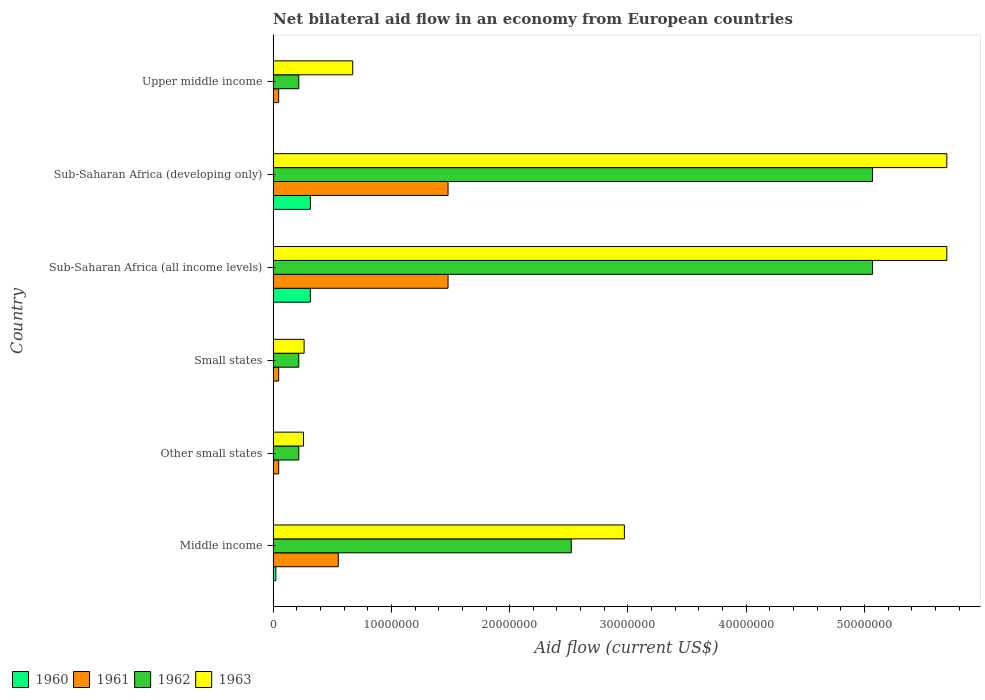How many groups of bars are there?
Your answer should be very brief. 6. How many bars are there on the 4th tick from the top?
Your answer should be compact. 4. What is the label of the 1st group of bars from the top?
Provide a succinct answer. Upper middle income. In how many cases, is the number of bars for a given country not equal to the number of legend labels?
Ensure brevity in your answer.  0. What is the net bilateral aid flow in 1962 in Small states?
Your answer should be compact. 2.17e+06. Across all countries, what is the maximum net bilateral aid flow in 1960?
Your response must be concise. 3.15e+06. Across all countries, what is the minimum net bilateral aid flow in 1962?
Give a very brief answer. 2.17e+06. In which country was the net bilateral aid flow in 1960 maximum?
Provide a short and direct response. Sub-Saharan Africa (all income levels). In which country was the net bilateral aid flow in 1963 minimum?
Keep it short and to the point. Other small states. What is the total net bilateral aid flow in 1963 in the graph?
Your answer should be very brief. 1.56e+08. What is the difference between the net bilateral aid flow in 1960 in Middle income and the net bilateral aid flow in 1962 in Upper middle income?
Your response must be concise. -1.94e+06. What is the average net bilateral aid flow in 1963 per country?
Your answer should be compact. 2.59e+07. What is the difference between the net bilateral aid flow in 1962 and net bilateral aid flow in 1961 in Middle income?
Keep it short and to the point. 1.97e+07. What is the ratio of the net bilateral aid flow in 1962 in Sub-Saharan Africa (developing only) to that in Upper middle income?
Ensure brevity in your answer.  23.35. Is the difference between the net bilateral aid flow in 1962 in Small states and Sub-Saharan Africa (all income levels) greater than the difference between the net bilateral aid flow in 1961 in Small states and Sub-Saharan Africa (all income levels)?
Your answer should be compact. No. What is the difference between the highest and the second highest net bilateral aid flow in 1962?
Your answer should be compact. 0. What is the difference between the highest and the lowest net bilateral aid flow in 1962?
Give a very brief answer. 4.85e+07. Is the sum of the net bilateral aid flow in 1962 in Small states and Sub-Saharan Africa (developing only) greater than the maximum net bilateral aid flow in 1961 across all countries?
Provide a short and direct response. Yes. What does the 4th bar from the top in Middle income represents?
Your answer should be compact. 1960. How many bars are there?
Your answer should be very brief. 24. Does the graph contain grids?
Provide a succinct answer. No. Where does the legend appear in the graph?
Your answer should be very brief. Bottom left. What is the title of the graph?
Offer a terse response. Net bilateral aid flow in an economy from European countries. Does "2005" appear as one of the legend labels in the graph?
Your answer should be compact. No. What is the label or title of the Y-axis?
Make the answer very short. Country. What is the Aid flow (current US$) in 1960 in Middle income?
Keep it short and to the point. 2.30e+05. What is the Aid flow (current US$) of 1961 in Middle income?
Keep it short and to the point. 5.51e+06. What is the Aid flow (current US$) in 1962 in Middle income?
Provide a short and direct response. 2.52e+07. What is the Aid flow (current US$) in 1963 in Middle income?
Your answer should be very brief. 2.97e+07. What is the Aid flow (current US$) in 1960 in Other small states?
Offer a terse response. 10000. What is the Aid flow (current US$) of 1962 in Other small states?
Give a very brief answer. 2.17e+06. What is the Aid flow (current US$) in 1963 in Other small states?
Give a very brief answer. 2.57e+06. What is the Aid flow (current US$) in 1962 in Small states?
Your answer should be very brief. 2.17e+06. What is the Aid flow (current US$) in 1963 in Small states?
Make the answer very short. 2.62e+06. What is the Aid flow (current US$) of 1960 in Sub-Saharan Africa (all income levels)?
Your answer should be compact. 3.15e+06. What is the Aid flow (current US$) of 1961 in Sub-Saharan Africa (all income levels)?
Keep it short and to the point. 1.48e+07. What is the Aid flow (current US$) in 1962 in Sub-Saharan Africa (all income levels)?
Your response must be concise. 5.07e+07. What is the Aid flow (current US$) of 1963 in Sub-Saharan Africa (all income levels)?
Your response must be concise. 5.70e+07. What is the Aid flow (current US$) in 1960 in Sub-Saharan Africa (developing only)?
Give a very brief answer. 3.15e+06. What is the Aid flow (current US$) in 1961 in Sub-Saharan Africa (developing only)?
Your answer should be compact. 1.48e+07. What is the Aid flow (current US$) in 1962 in Sub-Saharan Africa (developing only)?
Your answer should be compact. 5.07e+07. What is the Aid flow (current US$) of 1963 in Sub-Saharan Africa (developing only)?
Your answer should be very brief. 5.70e+07. What is the Aid flow (current US$) of 1961 in Upper middle income?
Your answer should be very brief. 4.70e+05. What is the Aid flow (current US$) of 1962 in Upper middle income?
Your response must be concise. 2.17e+06. What is the Aid flow (current US$) in 1963 in Upper middle income?
Your response must be concise. 6.73e+06. Across all countries, what is the maximum Aid flow (current US$) in 1960?
Offer a very short reply. 3.15e+06. Across all countries, what is the maximum Aid flow (current US$) of 1961?
Make the answer very short. 1.48e+07. Across all countries, what is the maximum Aid flow (current US$) in 1962?
Give a very brief answer. 5.07e+07. Across all countries, what is the maximum Aid flow (current US$) of 1963?
Your response must be concise. 5.70e+07. Across all countries, what is the minimum Aid flow (current US$) of 1960?
Ensure brevity in your answer.  10000. Across all countries, what is the minimum Aid flow (current US$) of 1961?
Make the answer very short. 4.70e+05. Across all countries, what is the minimum Aid flow (current US$) of 1962?
Offer a very short reply. 2.17e+06. Across all countries, what is the minimum Aid flow (current US$) of 1963?
Provide a short and direct response. 2.57e+06. What is the total Aid flow (current US$) in 1960 in the graph?
Your response must be concise. 6.56e+06. What is the total Aid flow (current US$) in 1961 in the graph?
Provide a short and direct response. 3.65e+07. What is the total Aid flow (current US$) of 1962 in the graph?
Provide a short and direct response. 1.33e+08. What is the total Aid flow (current US$) in 1963 in the graph?
Offer a terse response. 1.56e+08. What is the difference between the Aid flow (current US$) of 1960 in Middle income and that in Other small states?
Keep it short and to the point. 2.20e+05. What is the difference between the Aid flow (current US$) of 1961 in Middle income and that in Other small states?
Provide a short and direct response. 5.04e+06. What is the difference between the Aid flow (current US$) of 1962 in Middle income and that in Other small states?
Give a very brief answer. 2.30e+07. What is the difference between the Aid flow (current US$) of 1963 in Middle income and that in Other small states?
Your answer should be very brief. 2.71e+07. What is the difference between the Aid flow (current US$) of 1960 in Middle income and that in Small states?
Your response must be concise. 2.20e+05. What is the difference between the Aid flow (current US$) of 1961 in Middle income and that in Small states?
Your answer should be very brief. 5.04e+06. What is the difference between the Aid flow (current US$) of 1962 in Middle income and that in Small states?
Ensure brevity in your answer.  2.30e+07. What is the difference between the Aid flow (current US$) in 1963 in Middle income and that in Small states?
Ensure brevity in your answer.  2.71e+07. What is the difference between the Aid flow (current US$) of 1960 in Middle income and that in Sub-Saharan Africa (all income levels)?
Your response must be concise. -2.92e+06. What is the difference between the Aid flow (current US$) in 1961 in Middle income and that in Sub-Saharan Africa (all income levels)?
Provide a short and direct response. -9.28e+06. What is the difference between the Aid flow (current US$) in 1962 in Middle income and that in Sub-Saharan Africa (all income levels)?
Your response must be concise. -2.55e+07. What is the difference between the Aid flow (current US$) in 1963 in Middle income and that in Sub-Saharan Africa (all income levels)?
Your answer should be compact. -2.73e+07. What is the difference between the Aid flow (current US$) of 1960 in Middle income and that in Sub-Saharan Africa (developing only)?
Provide a short and direct response. -2.92e+06. What is the difference between the Aid flow (current US$) in 1961 in Middle income and that in Sub-Saharan Africa (developing only)?
Offer a terse response. -9.28e+06. What is the difference between the Aid flow (current US$) of 1962 in Middle income and that in Sub-Saharan Africa (developing only)?
Offer a terse response. -2.55e+07. What is the difference between the Aid flow (current US$) of 1963 in Middle income and that in Sub-Saharan Africa (developing only)?
Keep it short and to the point. -2.73e+07. What is the difference between the Aid flow (current US$) in 1961 in Middle income and that in Upper middle income?
Offer a very short reply. 5.04e+06. What is the difference between the Aid flow (current US$) of 1962 in Middle income and that in Upper middle income?
Your answer should be very brief. 2.30e+07. What is the difference between the Aid flow (current US$) of 1963 in Middle income and that in Upper middle income?
Ensure brevity in your answer.  2.30e+07. What is the difference between the Aid flow (current US$) in 1960 in Other small states and that in Sub-Saharan Africa (all income levels)?
Your answer should be very brief. -3.14e+06. What is the difference between the Aid flow (current US$) of 1961 in Other small states and that in Sub-Saharan Africa (all income levels)?
Make the answer very short. -1.43e+07. What is the difference between the Aid flow (current US$) of 1962 in Other small states and that in Sub-Saharan Africa (all income levels)?
Your response must be concise. -4.85e+07. What is the difference between the Aid flow (current US$) of 1963 in Other small states and that in Sub-Saharan Africa (all income levels)?
Your response must be concise. -5.44e+07. What is the difference between the Aid flow (current US$) in 1960 in Other small states and that in Sub-Saharan Africa (developing only)?
Your answer should be compact. -3.14e+06. What is the difference between the Aid flow (current US$) in 1961 in Other small states and that in Sub-Saharan Africa (developing only)?
Offer a very short reply. -1.43e+07. What is the difference between the Aid flow (current US$) of 1962 in Other small states and that in Sub-Saharan Africa (developing only)?
Ensure brevity in your answer.  -4.85e+07. What is the difference between the Aid flow (current US$) in 1963 in Other small states and that in Sub-Saharan Africa (developing only)?
Offer a terse response. -5.44e+07. What is the difference between the Aid flow (current US$) of 1960 in Other small states and that in Upper middle income?
Your answer should be very brief. 0. What is the difference between the Aid flow (current US$) in 1961 in Other small states and that in Upper middle income?
Ensure brevity in your answer.  0. What is the difference between the Aid flow (current US$) in 1962 in Other small states and that in Upper middle income?
Make the answer very short. 0. What is the difference between the Aid flow (current US$) in 1963 in Other small states and that in Upper middle income?
Ensure brevity in your answer.  -4.16e+06. What is the difference between the Aid flow (current US$) in 1960 in Small states and that in Sub-Saharan Africa (all income levels)?
Provide a succinct answer. -3.14e+06. What is the difference between the Aid flow (current US$) in 1961 in Small states and that in Sub-Saharan Africa (all income levels)?
Offer a terse response. -1.43e+07. What is the difference between the Aid flow (current US$) in 1962 in Small states and that in Sub-Saharan Africa (all income levels)?
Your response must be concise. -4.85e+07. What is the difference between the Aid flow (current US$) in 1963 in Small states and that in Sub-Saharan Africa (all income levels)?
Give a very brief answer. -5.43e+07. What is the difference between the Aid flow (current US$) of 1960 in Small states and that in Sub-Saharan Africa (developing only)?
Your answer should be very brief. -3.14e+06. What is the difference between the Aid flow (current US$) of 1961 in Small states and that in Sub-Saharan Africa (developing only)?
Give a very brief answer. -1.43e+07. What is the difference between the Aid flow (current US$) of 1962 in Small states and that in Sub-Saharan Africa (developing only)?
Offer a very short reply. -4.85e+07. What is the difference between the Aid flow (current US$) of 1963 in Small states and that in Sub-Saharan Africa (developing only)?
Give a very brief answer. -5.43e+07. What is the difference between the Aid flow (current US$) of 1963 in Small states and that in Upper middle income?
Make the answer very short. -4.11e+06. What is the difference between the Aid flow (current US$) in 1960 in Sub-Saharan Africa (all income levels) and that in Sub-Saharan Africa (developing only)?
Ensure brevity in your answer.  0. What is the difference between the Aid flow (current US$) in 1961 in Sub-Saharan Africa (all income levels) and that in Sub-Saharan Africa (developing only)?
Give a very brief answer. 0. What is the difference between the Aid flow (current US$) of 1962 in Sub-Saharan Africa (all income levels) and that in Sub-Saharan Africa (developing only)?
Give a very brief answer. 0. What is the difference between the Aid flow (current US$) of 1963 in Sub-Saharan Africa (all income levels) and that in Sub-Saharan Africa (developing only)?
Offer a very short reply. 0. What is the difference between the Aid flow (current US$) in 1960 in Sub-Saharan Africa (all income levels) and that in Upper middle income?
Offer a terse response. 3.14e+06. What is the difference between the Aid flow (current US$) of 1961 in Sub-Saharan Africa (all income levels) and that in Upper middle income?
Offer a very short reply. 1.43e+07. What is the difference between the Aid flow (current US$) of 1962 in Sub-Saharan Africa (all income levels) and that in Upper middle income?
Keep it short and to the point. 4.85e+07. What is the difference between the Aid flow (current US$) of 1963 in Sub-Saharan Africa (all income levels) and that in Upper middle income?
Offer a very short reply. 5.02e+07. What is the difference between the Aid flow (current US$) of 1960 in Sub-Saharan Africa (developing only) and that in Upper middle income?
Your answer should be compact. 3.14e+06. What is the difference between the Aid flow (current US$) of 1961 in Sub-Saharan Africa (developing only) and that in Upper middle income?
Offer a very short reply. 1.43e+07. What is the difference between the Aid flow (current US$) in 1962 in Sub-Saharan Africa (developing only) and that in Upper middle income?
Ensure brevity in your answer.  4.85e+07. What is the difference between the Aid flow (current US$) of 1963 in Sub-Saharan Africa (developing only) and that in Upper middle income?
Offer a very short reply. 5.02e+07. What is the difference between the Aid flow (current US$) of 1960 in Middle income and the Aid flow (current US$) of 1961 in Other small states?
Your response must be concise. -2.40e+05. What is the difference between the Aid flow (current US$) of 1960 in Middle income and the Aid flow (current US$) of 1962 in Other small states?
Keep it short and to the point. -1.94e+06. What is the difference between the Aid flow (current US$) of 1960 in Middle income and the Aid flow (current US$) of 1963 in Other small states?
Ensure brevity in your answer.  -2.34e+06. What is the difference between the Aid flow (current US$) in 1961 in Middle income and the Aid flow (current US$) in 1962 in Other small states?
Provide a succinct answer. 3.34e+06. What is the difference between the Aid flow (current US$) in 1961 in Middle income and the Aid flow (current US$) in 1963 in Other small states?
Provide a succinct answer. 2.94e+06. What is the difference between the Aid flow (current US$) of 1962 in Middle income and the Aid flow (current US$) of 1963 in Other small states?
Your response must be concise. 2.26e+07. What is the difference between the Aid flow (current US$) in 1960 in Middle income and the Aid flow (current US$) in 1961 in Small states?
Your response must be concise. -2.40e+05. What is the difference between the Aid flow (current US$) of 1960 in Middle income and the Aid flow (current US$) of 1962 in Small states?
Offer a very short reply. -1.94e+06. What is the difference between the Aid flow (current US$) of 1960 in Middle income and the Aid flow (current US$) of 1963 in Small states?
Your answer should be very brief. -2.39e+06. What is the difference between the Aid flow (current US$) in 1961 in Middle income and the Aid flow (current US$) in 1962 in Small states?
Offer a very short reply. 3.34e+06. What is the difference between the Aid flow (current US$) of 1961 in Middle income and the Aid flow (current US$) of 1963 in Small states?
Offer a terse response. 2.89e+06. What is the difference between the Aid flow (current US$) in 1962 in Middle income and the Aid flow (current US$) in 1963 in Small states?
Make the answer very short. 2.26e+07. What is the difference between the Aid flow (current US$) in 1960 in Middle income and the Aid flow (current US$) in 1961 in Sub-Saharan Africa (all income levels)?
Provide a short and direct response. -1.46e+07. What is the difference between the Aid flow (current US$) in 1960 in Middle income and the Aid flow (current US$) in 1962 in Sub-Saharan Africa (all income levels)?
Your response must be concise. -5.04e+07. What is the difference between the Aid flow (current US$) in 1960 in Middle income and the Aid flow (current US$) in 1963 in Sub-Saharan Africa (all income levels)?
Your answer should be compact. -5.67e+07. What is the difference between the Aid flow (current US$) of 1961 in Middle income and the Aid flow (current US$) of 1962 in Sub-Saharan Africa (all income levels)?
Your answer should be very brief. -4.52e+07. What is the difference between the Aid flow (current US$) in 1961 in Middle income and the Aid flow (current US$) in 1963 in Sub-Saharan Africa (all income levels)?
Offer a very short reply. -5.14e+07. What is the difference between the Aid flow (current US$) in 1962 in Middle income and the Aid flow (current US$) in 1963 in Sub-Saharan Africa (all income levels)?
Ensure brevity in your answer.  -3.18e+07. What is the difference between the Aid flow (current US$) of 1960 in Middle income and the Aid flow (current US$) of 1961 in Sub-Saharan Africa (developing only)?
Your answer should be compact. -1.46e+07. What is the difference between the Aid flow (current US$) of 1960 in Middle income and the Aid flow (current US$) of 1962 in Sub-Saharan Africa (developing only)?
Offer a very short reply. -5.04e+07. What is the difference between the Aid flow (current US$) of 1960 in Middle income and the Aid flow (current US$) of 1963 in Sub-Saharan Africa (developing only)?
Make the answer very short. -5.67e+07. What is the difference between the Aid flow (current US$) in 1961 in Middle income and the Aid flow (current US$) in 1962 in Sub-Saharan Africa (developing only)?
Your response must be concise. -4.52e+07. What is the difference between the Aid flow (current US$) in 1961 in Middle income and the Aid flow (current US$) in 1963 in Sub-Saharan Africa (developing only)?
Provide a short and direct response. -5.14e+07. What is the difference between the Aid flow (current US$) in 1962 in Middle income and the Aid flow (current US$) in 1963 in Sub-Saharan Africa (developing only)?
Ensure brevity in your answer.  -3.18e+07. What is the difference between the Aid flow (current US$) of 1960 in Middle income and the Aid flow (current US$) of 1961 in Upper middle income?
Give a very brief answer. -2.40e+05. What is the difference between the Aid flow (current US$) of 1960 in Middle income and the Aid flow (current US$) of 1962 in Upper middle income?
Give a very brief answer. -1.94e+06. What is the difference between the Aid flow (current US$) of 1960 in Middle income and the Aid flow (current US$) of 1963 in Upper middle income?
Keep it short and to the point. -6.50e+06. What is the difference between the Aid flow (current US$) of 1961 in Middle income and the Aid flow (current US$) of 1962 in Upper middle income?
Make the answer very short. 3.34e+06. What is the difference between the Aid flow (current US$) of 1961 in Middle income and the Aid flow (current US$) of 1963 in Upper middle income?
Ensure brevity in your answer.  -1.22e+06. What is the difference between the Aid flow (current US$) of 1962 in Middle income and the Aid flow (current US$) of 1963 in Upper middle income?
Provide a short and direct response. 1.85e+07. What is the difference between the Aid flow (current US$) of 1960 in Other small states and the Aid flow (current US$) of 1961 in Small states?
Keep it short and to the point. -4.60e+05. What is the difference between the Aid flow (current US$) of 1960 in Other small states and the Aid flow (current US$) of 1962 in Small states?
Keep it short and to the point. -2.16e+06. What is the difference between the Aid flow (current US$) of 1960 in Other small states and the Aid flow (current US$) of 1963 in Small states?
Offer a very short reply. -2.61e+06. What is the difference between the Aid flow (current US$) of 1961 in Other small states and the Aid flow (current US$) of 1962 in Small states?
Keep it short and to the point. -1.70e+06. What is the difference between the Aid flow (current US$) of 1961 in Other small states and the Aid flow (current US$) of 1963 in Small states?
Your response must be concise. -2.15e+06. What is the difference between the Aid flow (current US$) in 1962 in Other small states and the Aid flow (current US$) in 1963 in Small states?
Ensure brevity in your answer.  -4.50e+05. What is the difference between the Aid flow (current US$) in 1960 in Other small states and the Aid flow (current US$) in 1961 in Sub-Saharan Africa (all income levels)?
Your answer should be very brief. -1.48e+07. What is the difference between the Aid flow (current US$) of 1960 in Other small states and the Aid flow (current US$) of 1962 in Sub-Saharan Africa (all income levels)?
Keep it short and to the point. -5.07e+07. What is the difference between the Aid flow (current US$) in 1960 in Other small states and the Aid flow (current US$) in 1963 in Sub-Saharan Africa (all income levels)?
Your answer should be very brief. -5.70e+07. What is the difference between the Aid flow (current US$) in 1961 in Other small states and the Aid flow (current US$) in 1962 in Sub-Saharan Africa (all income levels)?
Provide a short and direct response. -5.02e+07. What is the difference between the Aid flow (current US$) of 1961 in Other small states and the Aid flow (current US$) of 1963 in Sub-Saharan Africa (all income levels)?
Keep it short and to the point. -5.65e+07. What is the difference between the Aid flow (current US$) in 1962 in Other small states and the Aid flow (current US$) in 1963 in Sub-Saharan Africa (all income levels)?
Your answer should be very brief. -5.48e+07. What is the difference between the Aid flow (current US$) in 1960 in Other small states and the Aid flow (current US$) in 1961 in Sub-Saharan Africa (developing only)?
Keep it short and to the point. -1.48e+07. What is the difference between the Aid flow (current US$) of 1960 in Other small states and the Aid flow (current US$) of 1962 in Sub-Saharan Africa (developing only)?
Offer a very short reply. -5.07e+07. What is the difference between the Aid flow (current US$) of 1960 in Other small states and the Aid flow (current US$) of 1963 in Sub-Saharan Africa (developing only)?
Offer a terse response. -5.70e+07. What is the difference between the Aid flow (current US$) in 1961 in Other small states and the Aid flow (current US$) in 1962 in Sub-Saharan Africa (developing only)?
Make the answer very short. -5.02e+07. What is the difference between the Aid flow (current US$) of 1961 in Other small states and the Aid flow (current US$) of 1963 in Sub-Saharan Africa (developing only)?
Keep it short and to the point. -5.65e+07. What is the difference between the Aid flow (current US$) of 1962 in Other small states and the Aid flow (current US$) of 1963 in Sub-Saharan Africa (developing only)?
Offer a terse response. -5.48e+07. What is the difference between the Aid flow (current US$) in 1960 in Other small states and the Aid flow (current US$) in 1961 in Upper middle income?
Your answer should be very brief. -4.60e+05. What is the difference between the Aid flow (current US$) of 1960 in Other small states and the Aid flow (current US$) of 1962 in Upper middle income?
Make the answer very short. -2.16e+06. What is the difference between the Aid flow (current US$) of 1960 in Other small states and the Aid flow (current US$) of 1963 in Upper middle income?
Keep it short and to the point. -6.72e+06. What is the difference between the Aid flow (current US$) of 1961 in Other small states and the Aid flow (current US$) of 1962 in Upper middle income?
Give a very brief answer. -1.70e+06. What is the difference between the Aid flow (current US$) in 1961 in Other small states and the Aid flow (current US$) in 1963 in Upper middle income?
Provide a short and direct response. -6.26e+06. What is the difference between the Aid flow (current US$) of 1962 in Other small states and the Aid flow (current US$) of 1963 in Upper middle income?
Provide a short and direct response. -4.56e+06. What is the difference between the Aid flow (current US$) of 1960 in Small states and the Aid flow (current US$) of 1961 in Sub-Saharan Africa (all income levels)?
Your response must be concise. -1.48e+07. What is the difference between the Aid flow (current US$) in 1960 in Small states and the Aid flow (current US$) in 1962 in Sub-Saharan Africa (all income levels)?
Provide a succinct answer. -5.07e+07. What is the difference between the Aid flow (current US$) in 1960 in Small states and the Aid flow (current US$) in 1963 in Sub-Saharan Africa (all income levels)?
Give a very brief answer. -5.70e+07. What is the difference between the Aid flow (current US$) of 1961 in Small states and the Aid flow (current US$) of 1962 in Sub-Saharan Africa (all income levels)?
Offer a terse response. -5.02e+07. What is the difference between the Aid flow (current US$) in 1961 in Small states and the Aid flow (current US$) in 1963 in Sub-Saharan Africa (all income levels)?
Keep it short and to the point. -5.65e+07. What is the difference between the Aid flow (current US$) of 1962 in Small states and the Aid flow (current US$) of 1963 in Sub-Saharan Africa (all income levels)?
Your response must be concise. -5.48e+07. What is the difference between the Aid flow (current US$) in 1960 in Small states and the Aid flow (current US$) in 1961 in Sub-Saharan Africa (developing only)?
Your answer should be compact. -1.48e+07. What is the difference between the Aid flow (current US$) of 1960 in Small states and the Aid flow (current US$) of 1962 in Sub-Saharan Africa (developing only)?
Provide a short and direct response. -5.07e+07. What is the difference between the Aid flow (current US$) of 1960 in Small states and the Aid flow (current US$) of 1963 in Sub-Saharan Africa (developing only)?
Give a very brief answer. -5.70e+07. What is the difference between the Aid flow (current US$) of 1961 in Small states and the Aid flow (current US$) of 1962 in Sub-Saharan Africa (developing only)?
Your answer should be compact. -5.02e+07. What is the difference between the Aid flow (current US$) of 1961 in Small states and the Aid flow (current US$) of 1963 in Sub-Saharan Africa (developing only)?
Offer a very short reply. -5.65e+07. What is the difference between the Aid flow (current US$) in 1962 in Small states and the Aid flow (current US$) in 1963 in Sub-Saharan Africa (developing only)?
Give a very brief answer. -5.48e+07. What is the difference between the Aid flow (current US$) in 1960 in Small states and the Aid flow (current US$) in 1961 in Upper middle income?
Provide a short and direct response. -4.60e+05. What is the difference between the Aid flow (current US$) of 1960 in Small states and the Aid flow (current US$) of 1962 in Upper middle income?
Offer a terse response. -2.16e+06. What is the difference between the Aid flow (current US$) in 1960 in Small states and the Aid flow (current US$) in 1963 in Upper middle income?
Your response must be concise. -6.72e+06. What is the difference between the Aid flow (current US$) of 1961 in Small states and the Aid flow (current US$) of 1962 in Upper middle income?
Provide a succinct answer. -1.70e+06. What is the difference between the Aid flow (current US$) in 1961 in Small states and the Aid flow (current US$) in 1963 in Upper middle income?
Provide a succinct answer. -6.26e+06. What is the difference between the Aid flow (current US$) of 1962 in Small states and the Aid flow (current US$) of 1963 in Upper middle income?
Your response must be concise. -4.56e+06. What is the difference between the Aid flow (current US$) in 1960 in Sub-Saharan Africa (all income levels) and the Aid flow (current US$) in 1961 in Sub-Saharan Africa (developing only)?
Give a very brief answer. -1.16e+07. What is the difference between the Aid flow (current US$) of 1960 in Sub-Saharan Africa (all income levels) and the Aid flow (current US$) of 1962 in Sub-Saharan Africa (developing only)?
Ensure brevity in your answer.  -4.75e+07. What is the difference between the Aid flow (current US$) in 1960 in Sub-Saharan Africa (all income levels) and the Aid flow (current US$) in 1963 in Sub-Saharan Africa (developing only)?
Give a very brief answer. -5.38e+07. What is the difference between the Aid flow (current US$) of 1961 in Sub-Saharan Africa (all income levels) and the Aid flow (current US$) of 1962 in Sub-Saharan Africa (developing only)?
Offer a terse response. -3.59e+07. What is the difference between the Aid flow (current US$) in 1961 in Sub-Saharan Africa (all income levels) and the Aid flow (current US$) in 1963 in Sub-Saharan Africa (developing only)?
Your answer should be very brief. -4.22e+07. What is the difference between the Aid flow (current US$) in 1962 in Sub-Saharan Africa (all income levels) and the Aid flow (current US$) in 1963 in Sub-Saharan Africa (developing only)?
Your answer should be compact. -6.28e+06. What is the difference between the Aid flow (current US$) of 1960 in Sub-Saharan Africa (all income levels) and the Aid flow (current US$) of 1961 in Upper middle income?
Give a very brief answer. 2.68e+06. What is the difference between the Aid flow (current US$) of 1960 in Sub-Saharan Africa (all income levels) and the Aid flow (current US$) of 1962 in Upper middle income?
Offer a terse response. 9.80e+05. What is the difference between the Aid flow (current US$) of 1960 in Sub-Saharan Africa (all income levels) and the Aid flow (current US$) of 1963 in Upper middle income?
Give a very brief answer. -3.58e+06. What is the difference between the Aid flow (current US$) in 1961 in Sub-Saharan Africa (all income levels) and the Aid flow (current US$) in 1962 in Upper middle income?
Provide a succinct answer. 1.26e+07. What is the difference between the Aid flow (current US$) of 1961 in Sub-Saharan Africa (all income levels) and the Aid flow (current US$) of 1963 in Upper middle income?
Give a very brief answer. 8.06e+06. What is the difference between the Aid flow (current US$) of 1962 in Sub-Saharan Africa (all income levels) and the Aid flow (current US$) of 1963 in Upper middle income?
Your answer should be very brief. 4.40e+07. What is the difference between the Aid flow (current US$) in 1960 in Sub-Saharan Africa (developing only) and the Aid flow (current US$) in 1961 in Upper middle income?
Offer a very short reply. 2.68e+06. What is the difference between the Aid flow (current US$) of 1960 in Sub-Saharan Africa (developing only) and the Aid flow (current US$) of 1962 in Upper middle income?
Your answer should be very brief. 9.80e+05. What is the difference between the Aid flow (current US$) of 1960 in Sub-Saharan Africa (developing only) and the Aid flow (current US$) of 1963 in Upper middle income?
Give a very brief answer. -3.58e+06. What is the difference between the Aid flow (current US$) in 1961 in Sub-Saharan Africa (developing only) and the Aid flow (current US$) in 1962 in Upper middle income?
Your answer should be compact. 1.26e+07. What is the difference between the Aid flow (current US$) of 1961 in Sub-Saharan Africa (developing only) and the Aid flow (current US$) of 1963 in Upper middle income?
Ensure brevity in your answer.  8.06e+06. What is the difference between the Aid flow (current US$) of 1962 in Sub-Saharan Africa (developing only) and the Aid flow (current US$) of 1963 in Upper middle income?
Make the answer very short. 4.40e+07. What is the average Aid flow (current US$) of 1960 per country?
Your answer should be compact. 1.09e+06. What is the average Aid flow (current US$) of 1961 per country?
Make the answer very short. 6.08e+06. What is the average Aid flow (current US$) in 1962 per country?
Your answer should be very brief. 2.22e+07. What is the average Aid flow (current US$) in 1963 per country?
Your answer should be compact. 2.59e+07. What is the difference between the Aid flow (current US$) in 1960 and Aid flow (current US$) in 1961 in Middle income?
Your answer should be compact. -5.28e+06. What is the difference between the Aid flow (current US$) in 1960 and Aid flow (current US$) in 1962 in Middle income?
Provide a succinct answer. -2.50e+07. What is the difference between the Aid flow (current US$) in 1960 and Aid flow (current US$) in 1963 in Middle income?
Offer a very short reply. -2.95e+07. What is the difference between the Aid flow (current US$) of 1961 and Aid flow (current US$) of 1962 in Middle income?
Ensure brevity in your answer.  -1.97e+07. What is the difference between the Aid flow (current US$) of 1961 and Aid flow (current US$) of 1963 in Middle income?
Make the answer very short. -2.42e+07. What is the difference between the Aid flow (current US$) in 1962 and Aid flow (current US$) in 1963 in Middle income?
Give a very brief answer. -4.49e+06. What is the difference between the Aid flow (current US$) of 1960 and Aid flow (current US$) of 1961 in Other small states?
Ensure brevity in your answer.  -4.60e+05. What is the difference between the Aid flow (current US$) of 1960 and Aid flow (current US$) of 1962 in Other small states?
Your response must be concise. -2.16e+06. What is the difference between the Aid flow (current US$) of 1960 and Aid flow (current US$) of 1963 in Other small states?
Ensure brevity in your answer.  -2.56e+06. What is the difference between the Aid flow (current US$) in 1961 and Aid flow (current US$) in 1962 in Other small states?
Ensure brevity in your answer.  -1.70e+06. What is the difference between the Aid flow (current US$) in 1961 and Aid flow (current US$) in 1963 in Other small states?
Provide a short and direct response. -2.10e+06. What is the difference between the Aid flow (current US$) of 1962 and Aid flow (current US$) of 1963 in Other small states?
Keep it short and to the point. -4.00e+05. What is the difference between the Aid flow (current US$) in 1960 and Aid flow (current US$) in 1961 in Small states?
Make the answer very short. -4.60e+05. What is the difference between the Aid flow (current US$) of 1960 and Aid flow (current US$) of 1962 in Small states?
Your answer should be compact. -2.16e+06. What is the difference between the Aid flow (current US$) in 1960 and Aid flow (current US$) in 1963 in Small states?
Your answer should be compact. -2.61e+06. What is the difference between the Aid flow (current US$) in 1961 and Aid flow (current US$) in 1962 in Small states?
Offer a terse response. -1.70e+06. What is the difference between the Aid flow (current US$) in 1961 and Aid flow (current US$) in 1963 in Small states?
Keep it short and to the point. -2.15e+06. What is the difference between the Aid flow (current US$) in 1962 and Aid flow (current US$) in 1963 in Small states?
Offer a very short reply. -4.50e+05. What is the difference between the Aid flow (current US$) in 1960 and Aid flow (current US$) in 1961 in Sub-Saharan Africa (all income levels)?
Give a very brief answer. -1.16e+07. What is the difference between the Aid flow (current US$) in 1960 and Aid flow (current US$) in 1962 in Sub-Saharan Africa (all income levels)?
Give a very brief answer. -4.75e+07. What is the difference between the Aid flow (current US$) of 1960 and Aid flow (current US$) of 1963 in Sub-Saharan Africa (all income levels)?
Keep it short and to the point. -5.38e+07. What is the difference between the Aid flow (current US$) in 1961 and Aid flow (current US$) in 1962 in Sub-Saharan Africa (all income levels)?
Provide a succinct answer. -3.59e+07. What is the difference between the Aid flow (current US$) in 1961 and Aid flow (current US$) in 1963 in Sub-Saharan Africa (all income levels)?
Keep it short and to the point. -4.22e+07. What is the difference between the Aid flow (current US$) in 1962 and Aid flow (current US$) in 1963 in Sub-Saharan Africa (all income levels)?
Provide a succinct answer. -6.28e+06. What is the difference between the Aid flow (current US$) in 1960 and Aid flow (current US$) in 1961 in Sub-Saharan Africa (developing only)?
Make the answer very short. -1.16e+07. What is the difference between the Aid flow (current US$) in 1960 and Aid flow (current US$) in 1962 in Sub-Saharan Africa (developing only)?
Provide a succinct answer. -4.75e+07. What is the difference between the Aid flow (current US$) of 1960 and Aid flow (current US$) of 1963 in Sub-Saharan Africa (developing only)?
Your answer should be compact. -5.38e+07. What is the difference between the Aid flow (current US$) in 1961 and Aid flow (current US$) in 1962 in Sub-Saharan Africa (developing only)?
Provide a short and direct response. -3.59e+07. What is the difference between the Aid flow (current US$) of 1961 and Aid flow (current US$) of 1963 in Sub-Saharan Africa (developing only)?
Ensure brevity in your answer.  -4.22e+07. What is the difference between the Aid flow (current US$) of 1962 and Aid flow (current US$) of 1963 in Sub-Saharan Africa (developing only)?
Keep it short and to the point. -6.28e+06. What is the difference between the Aid flow (current US$) in 1960 and Aid flow (current US$) in 1961 in Upper middle income?
Offer a very short reply. -4.60e+05. What is the difference between the Aid flow (current US$) in 1960 and Aid flow (current US$) in 1962 in Upper middle income?
Your answer should be compact. -2.16e+06. What is the difference between the Aid flow (current US$) of 1960 and Aid flow (current US$) of 1963 in Upper middle income?
Offer a terse response. -6.72e+06. What is the difference between the Aid flow (current US$) in 1961 and Aid flow (current US$) in 1962 in Upper middle income?
Keep it short and to the point. -1.70e+06. What is the difference between the Aid flow (current US$) of 1961 and Aid flow (current US$) of 1963 in Upper middle income?
Offer a very short reply. -6.26e+06. What is the difference between the Aid flow (current US$) in 1962 and Aid flow (current US$) in 1963 in Upper middle income?
Make the answer very short. -4.56e+06. What is the ratio of the Aid flow (current US$) of 1960 in Middle income to that in Other small states?
Ensure brevity in your answer.  23. What is the ratio of the Aid flow (current US$) of 1961 in Middle income to that in Other small states?
Offer a very short reply. 11.72. What is the ratio of the Aid flow (current US$) of 1962 in Middle income to that in Other small states?
Offer a terse response. 11.62. What is the ratio of the Aid flow (current US$) in 1963 in Middle income to that in Other small states?
Provide a short and direct response. 11.56. What is the ratio of the Aid flow (current US$) of 1961 in Middle income to that in Small states?
Provide a short and direct response. 11.72. What is the ratio of the Aid flow (current US$) in 1962 in Middle income to that in Small states?
Provide a succinct answer. 11.62. What is the ratio of the Aid flow (current US$) in 1963 in Middle income to that in Small states?
Your answer should be compact. 11.34. What is the ratio of the Aid flow (current US$) in 1960 in Middle income to that in Sub-Saharan Africa (all income levels)?
Your response must be concise. 0.07. What is the ratio of the Aid flow (current US$) of 1961 in Middle income to that in Sub-Saharan Africa (all income levels)?
Your response must be concise. 0.37. What is the ratio of the Aid flow (current US$) of 1962 in Middle income to that in Sub-Saharan Africa (all income levels)?
Give a very brief answer. 0.5. What is the ratio of the Aid flow (current US$) in 1963 in Middle income to that in Sub-Saharan Africa (all income levels)?
Offer a terse response. 0.52. What is the ratio of the Aid flow (current US$) in 1960 in Middle income to that in Sub-Saharan Africa (developing only)?
Your answer should be very brief. 0.07. What is the ratio of the Aid flow (current US$) of 1961 in Middle income to that in Sub-Saharan Africa (developing only)?
Give a very brief answer. 0.37. What is the ratio of the Aid flow (current US$) in 1962 in Middle income to that in Sub-Saharan Africa (developing only)?
Offer a terse response. 0.5. What is the ratio of the Aid flow (current US$) of 1963 in Middle income to that in Sub-Saharan Africa (developing only)?
Your response must be concise. 0.52. What is the ratio of the Aid flow (current US$) in 1960 in Middle income to that in Upper middle income?
Offer a very short reply. 23. What is the ratio of the Aid flow (current US$) of 1961 in Middle income to that in Upper middle income?
Your response must be concise. 11.72. What is the ratio of the Aid flow (current US$) in 1962 in Middle income to that in Upper middle income?
Your answer should be compact. 11.62. What is the ratio of the Aid flow (current US$) in 1963 in Middle income to that in Upper middle income?
Your answer should be very brief. 4.41. What is the ratio of the Aid flow (current US$) in 1960 in Other small states to that in Small states?
Ensure brevity in your answer.  1. What is the ratio of the Aid flow (current US$) in 1962 in Other small states to that in Small states?
Your answer should be very brief. 1. What is the ratio of the Aid flow (current US$) of 1963 in Other small states to that in Small states?
Your response must be concise. 0.98. What is the ratio of the Aid flow (current US$) in 1960 in Other small states to that in Sub-Saharan Africa (all income levels)?
Offer a terse response. 0. What is the ratio of the Aid flow (current US$) in 1961 in Other small states to that in Sub-Saharan Africa (all income levels)?
Your response must be concise. 0.03. What is the ratio of the Aid flow (current US$) in 1962 in Other small states to that in Sub-Saharan Africa (all income levels)?
Ensure brevity in your answer.  0.04. What is the ratio of the Aid flow (current US$) of 1963 in Other small states to that in Sub-Saharan Africa (all income levels)?
Offer a very short reply. 0.05. What is the ratio of the Aid flow (current US$) of 1960 in Other small states to that in Sub-Saharan Africa (developing only)?
Make the answer very short. 0. What is the ratio of the Aid flow (current US$) of 1961 in Other small states to that in Sub-Saharan Africa (developing only)?
Your answer should be very brief. 0.03. What is the ratio of the Aid flow (current US$) in 1962 in Other small states to that in Sub-Saharan Africa (developing only)?
Provide a succinct answer. 0.04. What is the ratio of the Aid flow (current US$) of 1963 in Other small states to that in Sub-Saharan Africa (developing only)?
Offer a very short reply. 0.05. What is the ratio of the Aid flow (current US$) of 1961 in Other small states to that in Upper middle income?
Your answer should be very brief. 1. What is the ratio of the Aid flow (current US$) in 1963 in Other small states to that in Upper middle income?
Offer a very short reply. 0.38. What is the ratio of the Aid flow (current US$) in 1960 in Small states to that in Sub-Saharan Africa (all income levels)?
Provide a short and direct response. 0. What is the ratio of the Aid flow (current US$) in 1961 in Small states to that in Sub-Saharan Africa (all income levels)?
Provide a short and direct response. 0.03. What is the ratio of the Aid flow (current US$) of 1962 in Small states to that in Sub-Saharan Africa (all income levels)?
Make the answer very short. 0.04. What is the ratio of the Aid flow (current US$) of 1963 in Small states to that in Sub-Saharan Africa (all income levels)?
Provide a succinct answer. 0.05. What is the ratio of the Aid flow (current US$) in 1960 in Small states to that in Sub-Saharan Africa (developing only)?
Offer a very short reply. 0. What is the ratio of the Aid flow (current US$) of 1961 in Small states to that in Sub-Saharan Africa (developing only)?
Give a very brief answer. 0.03. What is the ratio of the Aid flow (current US$) of 1962 in Small states to that in Sub-Saharan Africa (developing only)?
Offer a very short reply. 0.04. What is the ratio of the Aid flow (current US$) of 1963 in Small states to that in Sub-Saharan Africa (developing only)?
Give a very brief answer. 0.05. What is the ratio of the Aid flow (current US$) of 1960 in Small states to that in Upper middle income?
Give a very brief answer. 1. What is the ratio of the Aid flow (current US$) in 1961 in Small states to that in Upper middle income?
Ensure brevity in your answer.  1. What is the ratio of the Aid flow (current US$) in 1963 in Small states to that in Upper middle income?
Offer a terse response. 0.39. What is the ratio of the Aid flow (current US$) of 1962 in Sub-Saharan Africa (all income levels) to that in Sub-Saharan Africa (developing only)?
Make the answer very short. 1. What is the ratio of the Aid flow (current US$) of 1963 in Sub-Saharan Africa (all income levels) to that in Sub-Saharan Africa (developing only)?
Ensure brevity in your answer.  1. What is the ratio of the Aid flow (current US$) in 1960 in Sub-Saharan Africa (all income levels) to that in Upper middle income?
Ensure brevity in your answer.  315. What is the ratio of the Aid flow (current US$) of 1961 in Sub-Saharan Africa (all income levels) to that in Upper middle income?
Offer a terse response. 31.47. What is the ratio of the Aid flow (current US$) in 1962 in Sub-Saharan Africa (all income levels) to that in Upper middle income?
Your answer should be very brief. 23.35. What is the ratio of the Aid flow (current US$) in 1963 in Sub-Saharan Africa (all income levels) to that in Upper middle income?
Offer a very short reply. 8.46. What is the ratio of the Aid flow (current US$) of 1960 in Sub-Saharan Africa (developing only) to that in Upper middle income?
Give a very brief answer. 315. What is the ratio of the Aid flow (current US$) in 1961 in Sub-Saharan Africa (developing only) to that in Upper middle income?
Provide a succinct answer. 31.47. What is the ratio of the Aid flow (current US$) in 1962 in Sub-Saharan Africa (developing only) to that in Upper middle income?
Make the answer very short. 23.35. What is the ratio of the Aid flow (current US$) in 1963 in Sub-Saharan Africa (developing only) to that in Upper middle income?
Offer a terse response. 8.46. What is the difference between the highest and the second highest Aid flow (current US$) of 1960?
Keep it short and to the point. 0. What is the difference between the highest and the second highest Aid flow (current US$) of 1962?
Give a very brief answer. 0. What is the difference between the highest and the lowest Aid flow (current US$) of 1960?
Keep it short and to the point. 3.14e+06. What is the difference between the highest and the lowest Aid flow (current US$) in 1961?
Give a very brief answer. 1.43e+07. What is the difference between the highest and the lowest Aid flow (current US$) in 1962?
Ensure brevity in your answer.  4.85e+07. What is the difference between the highest and the lowest Aid flow (current US$) in 1963?
Make the answer very short. 5.44e+07. 